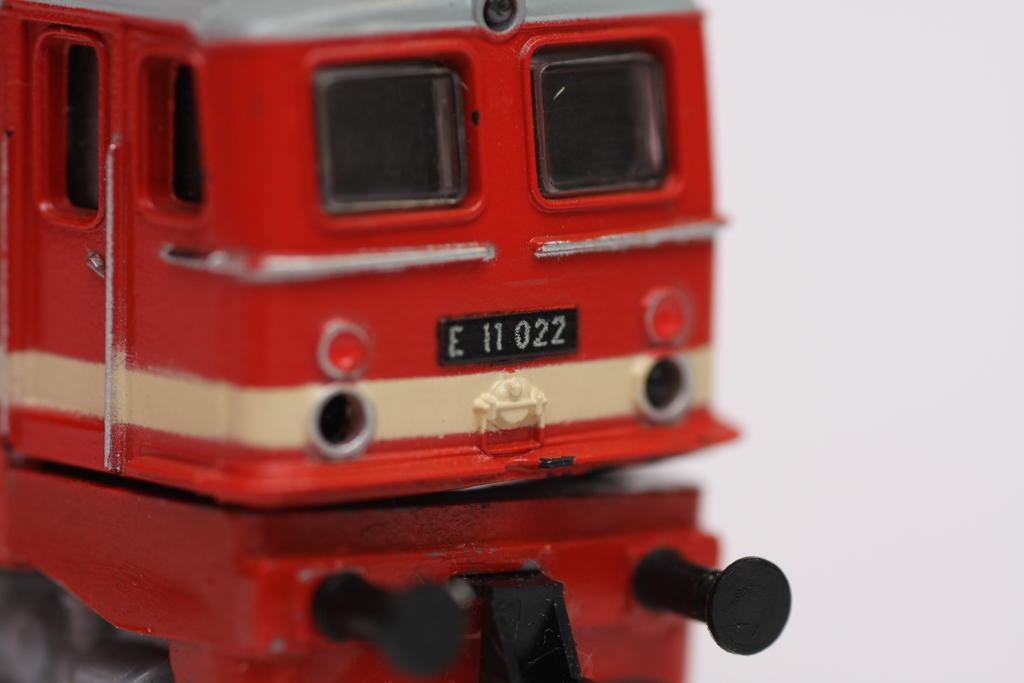Provide a one-sentence caption for the provided image. The rear end of train or subway with a black E11022 license plate. 